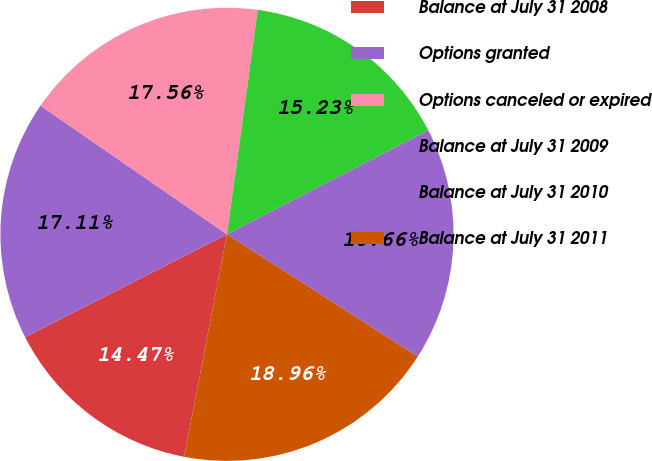Convert chart to OTSL. <chart><loc_0><loc_0><loc_500><loc_500><pie_chart><fcel>Balance at July 31 2008<fcel>Options granted<fcel>Options canceled or expired<fcel>Balance at July 31 2009<fcel>Balance at July 31 2010<fcel>Balance at July 31 2011<nl><fcel>14.47%<fcel>17.11%<fcel>17.56%<fcel>15.23%<fcel>16.66%<fcel>18.96%<nl></chart> 